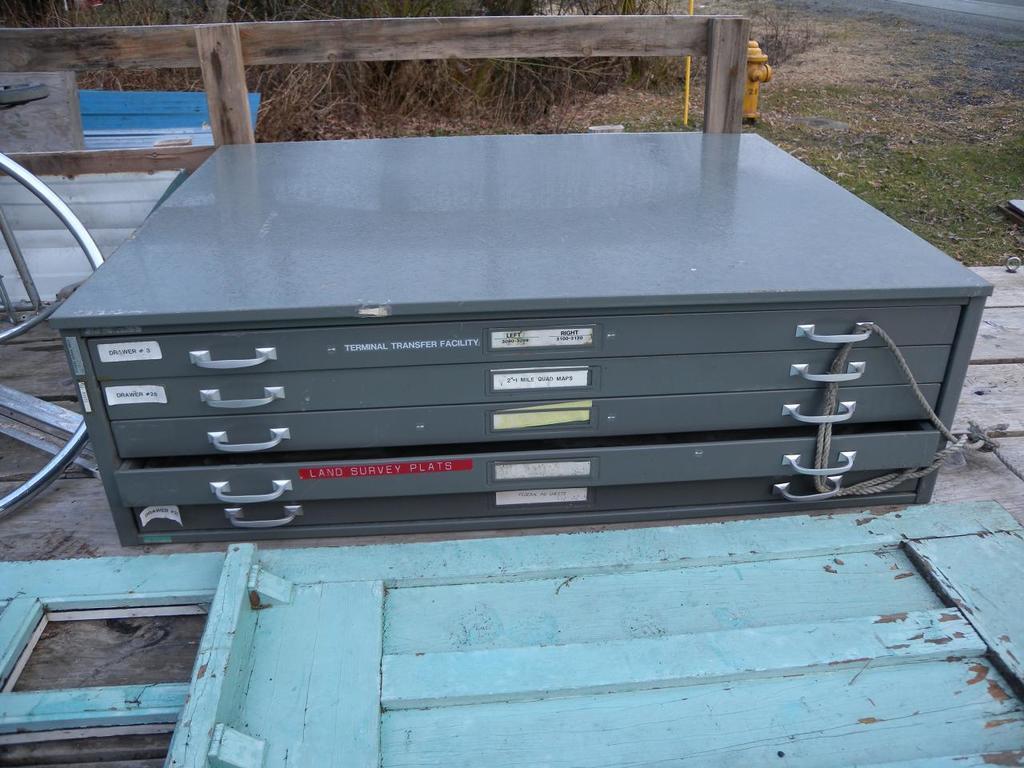In one or two sentences, can you explain what this image depicts? In this picture I can see cupboard. At the bottom there is a door. On the left I can see the wheel which is placed near to the wooden railing. In the top right there is a fire hydrant, beside that I can see the plants and grass. 